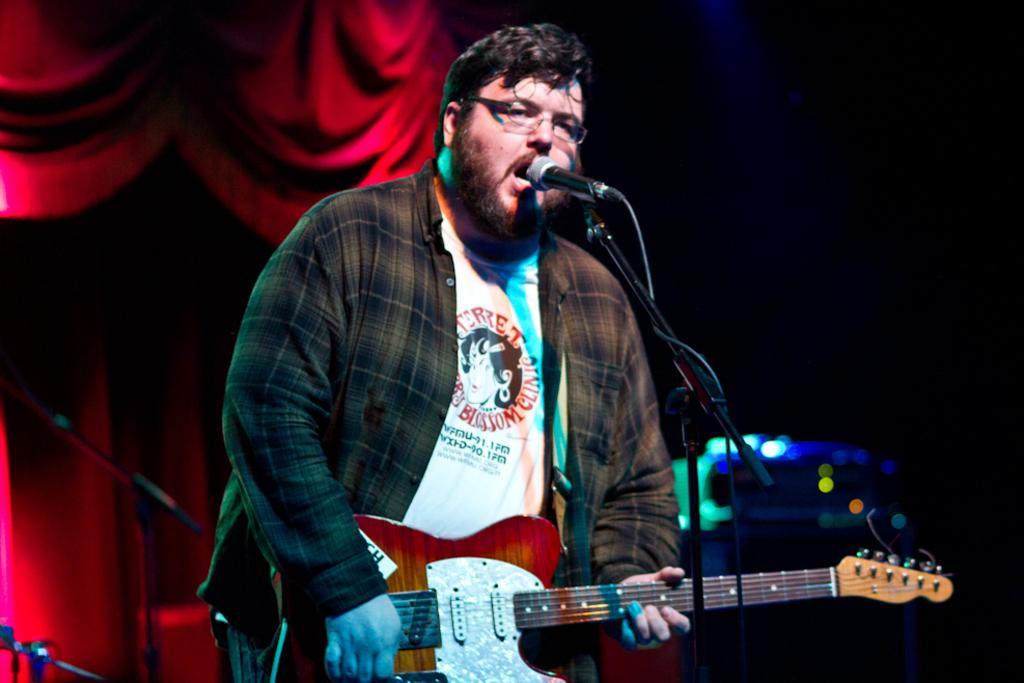Can you describe this image briefly? In this picture there is a man who is standing and playing the guitar and his also singing there is a microphone stand in front of him and in the background in red curtains 